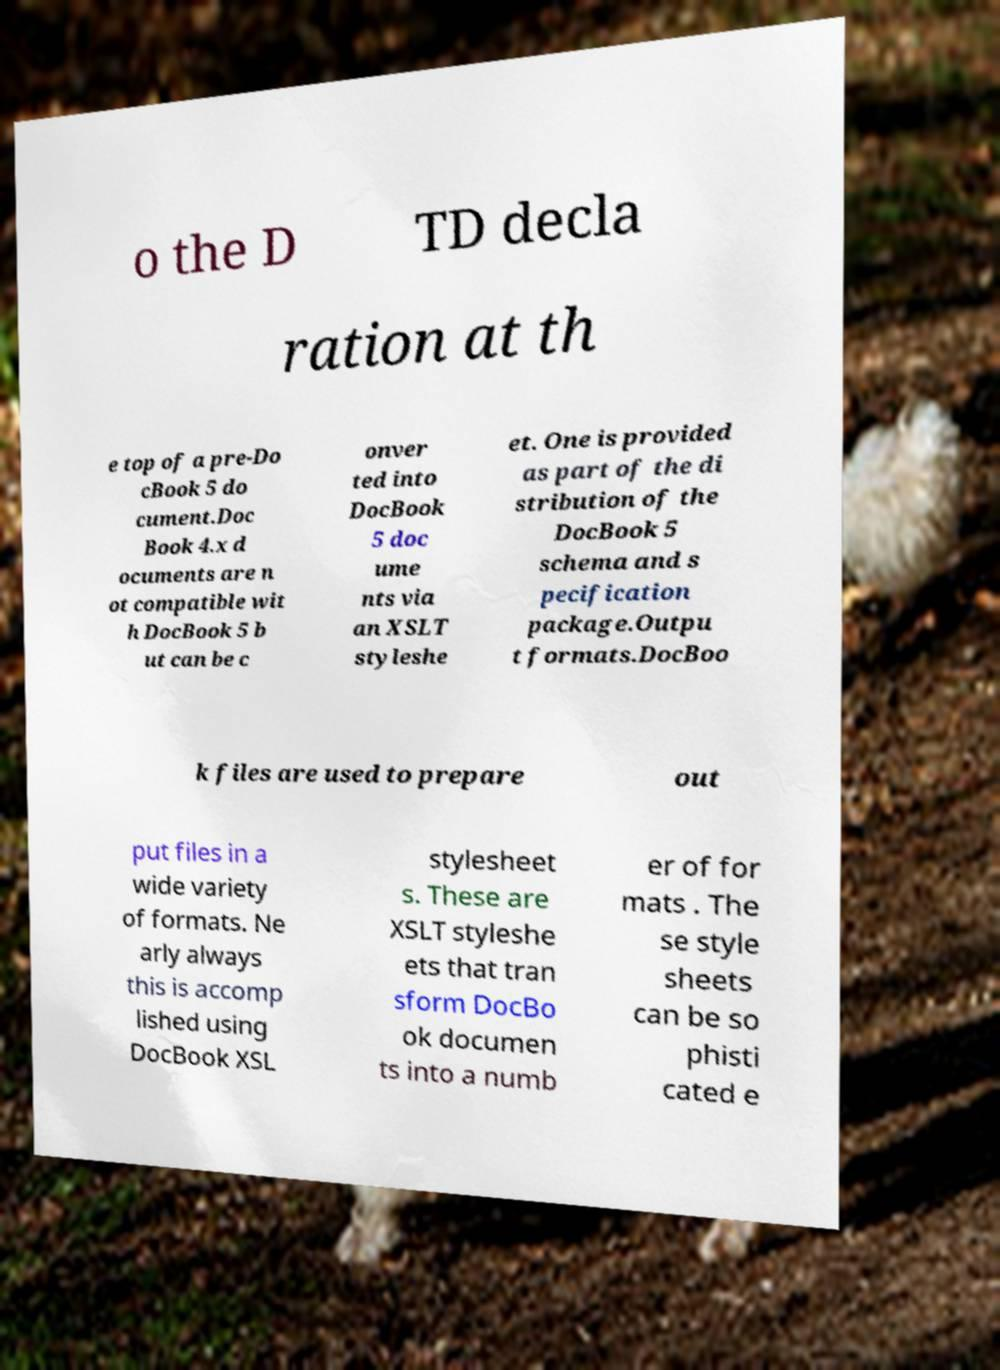There's text embedded in this image that I need extracted. Can you transcribe it verbatim? o the D TD decla ration at th e top of a pre-Do cBook 5 do cument.Doc Book 4.x d ocuments are n ot compatible wit h DocBook 5 b ut can be c onver ted into DocBook 5 doc ume nts via an XSLT styleshe et. One is provided as part of the di stribution of the DocBook 5 schema and s pecification package.Outpu t formats.DocBoo k files are used to prepare out put files in a wide variety of formats. Ne arly always this is accomp lished using DocBook XSL stylesheet s. These are XSLT styleshe ets that tran sform DocBo ok documen ts into a numb er of for mats . The se style sheets can be so phisti cated e 